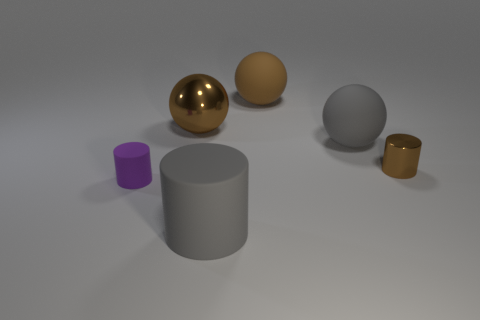Subtract all brown spheres. How many were subtracted if there are1brown spheres left? 1 Subtract all big rubber cylinders. How many cylinders are left? 2 Subtract 0 blue spheres. How many objects are left? 6 Subtract 3 balls. How many balls are left? 0 Subtract all gray cylinders. Subtract all green blocks. How many cylinders are left? 2 Subtract all gray blocks. How many yellow cylinders are left? 0 Subtract all metallic things. Subtract all brown matte spheres. How many objects are left? 3 Add 4 small brown metallic things. How many small brown metallic things are left? 5 Add 1 purple matte cylinders. How many purple matte cylinders exist? 2 Add 2 small purple matte objects. How many objects exist? 8 